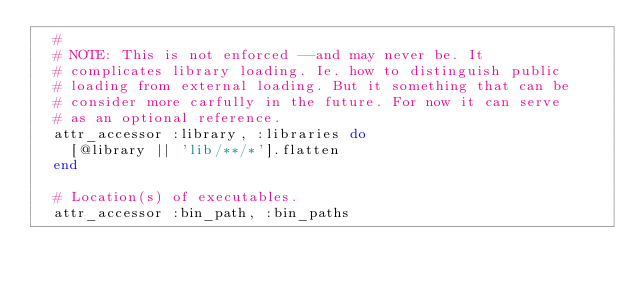Convert code to text. <code><loc_0><loc_0><loc_500><loc_500><_Ruby_>  #
  # NOTE: This is not enforced --and may never be. It
  # complicates library loading. Ie. how to distinguish public
  # loading from external loading. But it something that can be
  # consider more carfully in the future. For now it can serve
  # as an optional reference.
  attr_accessor :library, :libraries do
    [@library || 'lib/**/*'].flatten
  end

  # Location(s) of executables.
  attr_accessor :bin_path, :bin_paths
</code> 